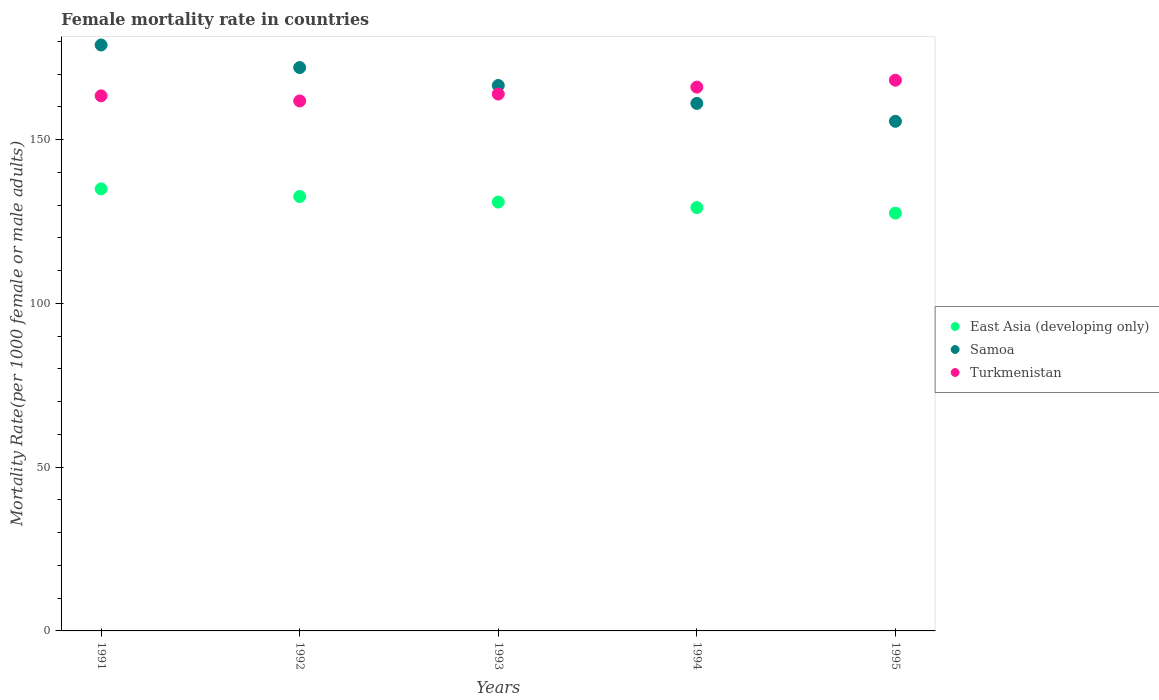How many different coloured dotlines are there?
Keep it short and to the point. 3. What is the female mortality rate in East Asia (developing only) in 1994?
Give a very brief answer. 129.27. Across all years, what is the maximum female mortality rate in Samoa?
Make the answer very short. 178.94. Across all years, what is the minimum female mortality rate in Turkmenistan?
Offer a terse response. 161.84. What is the total female mortality rate in Samoa in the graph?
Give a very brief answer. 834.26. What is the difference between the female mortality rate in Turkmenistan in 1992 and that in 1993?
Give a very brief answer. -2.11. What is the difference between the female mortality rate in Samoa in 1991 and the female mortality rate in East Asia (developing only) in 1992?
Your response must be concise. 46.28. What is the average female mortality rate in Samoa per year?
Your response must be concise. 166.85. In the year 1992, what is the difference between the female mortality rate in Samoa and female mortality rate in Turkmenistan?
Your answer should be compact. 10.2. In how many years, is the female mortality rate in Samoa greater than 40?
Make the answer very short. 5. What is the ratio of the female mortality rate in Samoa in 1992 to that in 1995?
Ensure brevity in your answer.  1.11. Is the difference between the female mortality rate in Samoa in 1992 and 1995 greater than the difference between the female mortality rate in Turkmenistan in 1992 and 1995?
Keep it short and to the point. Yes. What is the difference between the highest and the second highest female mortality rate in Samoa?
Your response must be concise. 6.9. What is the difference between the highest and the lowest female mortality rate in Turkmenistan?
Provide a short and direct response. 6.34. In how many years, is the female mortality rate in East Asia (developing only) greater than the average female mortality rate in East Asia (developing only) taken over all years?
Your response must be concise. 2. Is the sum of the female mortality rate in Turkmenistan in 1993 and 1995 greater than the maximum female mortality rate in East Asia (developing only) across all years?
Provide a succinct answer. Yes. How many dotlines are there?
Keep it short and to the point. 3. What is the difference between two consecutive major ticks on the Y-axis?
Your answer should be very brief. 50. Where does the legend appear in the graph?
Offer a terse response. Center right. How many legend labels are there?
Make the answer very short. 3. How are the legend labels stacked?
Ensure brevity in your answer.  Vertical. What is the title of the graph?
Ensure brevity in your answer.  Female mortality rate in countries. Does "Grenada" appear as one of the legend labels in the graph?
Your answer should be very brief. No. What is the label or title of the X-axis?
Offer a terse response. Years. What is the label or title of the Y-axis?
Keep it short and to the point. Mortality Rate(per 1000 female or male adults). What is the Mortality Rate(per 1000 female or male adults) of East Asia (developing only) in 1991?
Your answer should be very brief. 134.99. What is the Mortality Rate(per 1000 female or male adults) of Samoa in 1991?
Provide a succinct answer. 178.94. What is the Mortality Rate(per 1000 female or male adults) in Turkmenistan in 1991?
Your answer should be very brief. 163.41. What is the Mortality Rate(per 1000 female or male adults) of East Asia (developing only) in 1992?
Give a very brief answer. 132.66. What is the Mortality Rate(per 1000 female or male adults) in Samoa in 1992?
Offer a terse response. 172.04. What is the Mortality Rate(per 1000 female or male adults) in Turkmenistan in 1992?
Offer a terse response. 161.84. What is the Mortality Rate(per 1000 female or male adults) in East Asia (developing only) in 1993?
Your response must be concise. 130.96. What is the Mortality Rate(per 1000 female or male adults) in Samoa in 1993?
Your answer should be compact. 166.57. What is the Mortality Rate(per 1000 female or male adults) in Turkmenistan in 1993?
Your response must be concise. 163.95. What is the Mortality Rate(per 1000 female or male adults) in East Asia (developing only) in 1994?
Your answer should be very brief. 129.27. What is the Mortality Rate(per 1000 female or male adults) in Samoa in 1994?
Give a very brief answer. 161.1. What is the Mortality Rate(per 1000 female or male adults) in Turkmenistan in 1994?
Ensure brevity in your answer.  166.06. What is the Mortality Rate(per 1000 female or male adults) of East Asia (developing only) in 1995?
Your response must be concise. 127.59. What is the Mortality Rate(per 1000 female or male adults) of Samoa in 1995?
Ensure brevity in your answer.  155.63. What is the Mortality Rate(per 1000 female or male adults) in Turkmenistan in 1995?
Give a very brief answer. 168.18. Across all years, what is the maximum Mortality Rate(per 1000 female or male adults) of East Asia (developing only)?
Your answer should be very brief. 134.99. Across all years, what is the maximum Mortality Rate(per 1000 female or male adults) in Samoa?
Give a very brief answer. 178.94. Across all years, what is the maximum Mortality Rate(per 1000 female or male adults) of Turkmenistan?
Offer a very short reply. 168.18. Across all years, what is the minimum Mortality Rate(per 1000 female or male adults) of East Asia (developing only)?
Your answer should be very brief. 127.59. Across all years, what is the minimum Mortality Rate(per 1000 female or male adults) in Samoa?
Provide a short and direct response. 155.63. Across all years, what is the minimum Mortality Rate(per 1000 female or male adults) in Turkmenistan?
Your response must be concise. 161.84. What is the total Mortality Rate(per 1000 female or male adults) in East Asia (developing only) in the graph?
Offer a very short reply. 655.48. What is the total Mortality Rate(per 1000 female or male adults) of Samoa in the graph?
Provide a short and direct response. 834.26. What is the total Mortality Rate(per 1000 female or male adults) in Turkmenistan in the graph?
Offer a very short reply. 823.43. What is the difference between the Mortality Rate(per 1000 female or male adults) of East Asia (developing only) in 1991 and that in 1992?
Give a very brief answer. 2.33. What is the difference between the Mortality Rate(per 1000 female or male adults) of Samoa in 1991 and that in 1992?
Your response must be concise. 6.9. What is the difference between the Mortality Rate(per 1000 female or male adults) in Turkmenistan in 1991 and that in 1992?
Provide a short and direct response. 1.57. What is the difference between the Mortality Rate(per 1000 female or male adults) in East Asia (developing only) in 1991 and that in 1993?
Your response must be concise. 4.03. What is the difference between the Mortality Rate(per 1000 female or male adults) in Samoa in 1991 and that in 1993?
Give a very brief answer. 12.37. What is the difference between the Mortality Rate(per 1000 female or male adults) in Turkmenistan in 1991 and that in 1993?
Offer a terse response. -0.54. What is the difference between the Mortality Rate(per 1000 female or male adults) of East Asia (developing only) in 1991 and that in 1994?
Your response must be concise. 5.72. What is the difference between the Mortality Rate(per 1000 female or male adults) in Samoa in 1991 and that in 1994?
Keep it short and to the point. 17.84. What is the difference between the Mortality Rate(per 1000 female or male adults) of Turkmenistan in 1991 and that in 1994?
Make the answer very short. -2.65. What is the difference between the Mortality Rate(per 1000 female or male adults) in East Asia (developing only) in 1991 and that in 1995?
Offer a terse response. 7.4. What is the difference between the Mortality Rate(per 1000 female or male adults) in Samoa in 1991 and that in 1995?
Ensure brevity in your answer.  23.31. What is the difference between the Mortality Rate(per 1000 female or male adults) in Turkmenistan in 1991 and that in 1995?
Your response must be concise. -4.77. What is the difference between the Mortality Rate(per 1000 female or male adults) in East Asia (developing only) in 1992 and that in 1993?
Keep it short and to the point. 1.7. What is the difference between the Mortality Rate(per 1000 female or male adults) of Samoa in 1992 and that in 1993?
Offer a terse response. 5.47. What is the difference between the Mortality Rate(per 1000 female or male adults) in Turkmenistan in 1992 and that in 1993?
Your answer should be very brief. -2.11. What is the difference between the Mortality Rate(per 1000 female or male adults) in East Asia (developing only) in 1992 and that in 1994?
Offer a terse response. 3.39. What is the difference between the Mortality Rate(per 1000 female or male adults) in Samoa in 1992 and that in 1994?
Give a very brief answer. 10.94. What is the difference between the Mortality Rate(per 1000 female or male adults) of Turkmenistan in 1992 and that in 1994?
Ensure brevity in your answer.  -4.23. What is the difference between the Mortality Rate(per 1000 female or male adults) in East Asia (developing only) in 1992 and that in 1995?
Your answer should be compact. 5.07. What is the difference between the Mortality Rate(per 1000 female or male adults) in Samoa in 1992 and that in 1995?
Provide a succinct answer. 16.41. What is the difference between the Mortality Rate(per 1000 female or male adults) of Turkmenistan in 1992 and that in 1995?
Your response must be concise. -6.34. What is the difference between the Mortality Rate(per 1000 female or male adults) in East Asia (developing only) in 1993 and that in 1994?
Your answer should be very brief. 1.69. What is the difference between the Mortality Rate(per 1000 female or male adults) of Samoa in 1993 and that in 1994?
Make the answer very short. 5.47. What is the difference between the Mortality Rate(per 1000 female or male adults) in Turkmenistan in 1993 and that in 1994?
Provide a short and direct response. -2.11. What is the difference between the Mortality Rate(per 1000 female or male adults) in East Asia (developing only) in 1993 and that in 1995?
Your answer should be very brief. 3.37. What is the difference between the Mortality Rate(per 1000 female or male adults) of Samoa in 1993 and that in 1995?
Offer a very short reply. 10.94. What is the difference between the Mortality Rate(per 1000 female or male adults) of Turkmenistan in 1993 and that in 1995?
Keep it short and to the point. -4.23. What is the difference between the Mortality Rate(per 1000 female or male adults) of East Asia (developing only) in 1994 and that in 1995?
Make the answer very short. 1.68. What is the difference between the Mortality Rate(per 1000 female or male adults) in Samoa in 1994 and that in 1995?
Offer a very short reply. 5.47. What is the difference between the Mortality Rate(per 1000 female or male adults) in Turkmenistan in 1994 and that in 1995?
Your answer should be compact. -2.11. What is the difference between the Mortality Rate(per 1000 female or male adults) in East Asia (developing only) in 1991 and the Mortality Rate(per 1000 female or male adults) in Samoa in 1992?
Make the answer very short. -37.04. What is the difference between the Mortality Rate(per 1000 female or male adults) of East Asia (developing only) in 1991 and the Mortality Rate(per 1000 female or male adults) of Turkmenistan in 1992?
Your response must be concise. -26.84. What is the difference between the Mortality Rate(per 1000 female or male adults) in Samoa in 1991 and the Mortality Rate(per 1000 female or male adults) in Turkmenistan in 1992?
Your response must be concise. 17.1. What is the difference between the Mortality Rate(per 1000 female or male adults) in East Asia (developing only) in 1991 and the Mortality Rate(per 1000 female or male adults) in Samoa in 1993?
Your answer should be very brief. -31.57. What is the difference between the Mortality Rate(per 1000 female or male adults) in East Asia (developing only) in 1991 and the Mortality Rate(per 1000 female or male adults) in Turkmenistan in 1993?
Keep it short and to the point. -28.96. What is the difference between the Mortality Rate(per 1000 female or male adults) of Samoa in 1991 and the Mortality Rate(per 1000 female or male adults) of Turkmenistan in 1993?
Offer a very short reply. 14.99. What is the difference between the Mortality Rate(per 1000 female or male adults) of East Asia (developing only) in 1991 and the Mortality Rate(per 1000 female or male adults) of Samoa in 1994?
Provide a succinct answer. -26.1. What is the difference between the Mortality Rate(per 1000 female or male adults) of East Asia (developing only) in 1991 and the Mortality Rate(per 1000 female or male adults) of Turkmenistan in 1994?
Offer a terse response. -31.07. What is the difference between the Mortality Rate(per 1000 female or male adults) of Samoa in 1991 and the Mortality Rate(per 1000 female or male adults) of Turkmenistan in 1994?
Provide a short and direct response. 12.87. What is the difference between the Mortality Rate(per 1000 female or male adults) of East Asia (developing only) in 1991 and the Mortality Rate(per 1000 female or male adults) of Samoa in 1995?
Provide a succinct answer. -20.63. What is the difference between the Mortality Rate(per 1000 female or male adults) of East Asia (developing only) in 1991 and the Mortality Rate(per 1000 female or male adults) of Turkmenistan in 1995?
Offer a very short reply. -33.18. What is the difference between the Mortality Rate(per 1000 female or male adults) of Samoa in 1991 and the Mortality Rate(per 1000 female or male adults) of Turkmenistan in 1995?
Keep it short and to the point. 10.76. What is the difference between the Mortality Rate(per 1000 female or male adults) in East Asia (developing only) in 1992 and the Mortality Rate(per 1000 female or male adults) in Samoa in 1993?
Make the answer very short. -33.91. What is the difference between the Mortality Rate(per 1000 female or male adults) of East Asia (developing only) in 1992 and the Mortality Rate(per 1000 female or male adults) of Turkmenistan in 1993?
Your answer should be compact. -31.29. What is the difference between the Mortality Rate(per 1000 female or male adults) in Samoa in 1992 and the Mortality Rate(per 1000 female or male adults) in Turkmenistan in 1993?
Provide a short and direct response. 8.09. What is the difference between the Mortality Rate(per 1000 female or male adults) in East Asia (developing only) in 1992 and the Mortality Rate(per 1000 female or male adults) in Samoa in 1994?
Ensure brevity in your answer.  -28.44. What is the difference between the Mortality Rate(per 1000 female or male adults) in East Asia (developing only) in 1992 and the Mortality Rate(per 1000 female or male adults) in Turkmenistan in 1994?
Give a very brief answer. -33.4. What is the difference between the Mortality Rate(per 1000 female or male adults) of Samoa in 1992 and the Mortality Rate(per 1000 female or male adults) of Turkmenistan in 1994?
Ensure brevity in your answer.  5.97. What is the difference between the Mortality Rate(per 1000 female or male adults) of East Asia (developing only) in 1992 and the Mortality Rate(per 1000 female or male adults) of Samoa in 1995?
Keep it short and to the point. -22.97. What is the difference between the Mortality Rate(per 1000 female or male adults) of East Asia (developing only) in 1992 and the Mortality Rate(per 1000 female or male adults) of Turkmenistan in 1995?
Your response must be concise. -35.52. What is the difference between the Mortality Rate(per 1000 female or male adults) in Samoa in 1992 and the Mortality Rate(per 1000 female or male adults) in Turkmenistan in 1995?
Offer a terse response. 3.86. What is the difference between the Mortality Rate(per 1000 female or male adults) in East Asia (developing only) in 1993 and the Mortality Rate(per 1000 female or male adults) in Samoa in 1994?
Give a very brief answer. -30.13. What is the difference between the Mortality Rate(per 1000 female or male adults) of East Asia (developing only) in 1993 and the Mortality Rate(per 1000 female or male adults) of Turkmenistan in 1994?
Keep it short and to the point. -35.1. What is the difference between the Mortality Rate(per 1000 female or male adults) of Samoa in 1993 and the Mortality Rate(per 1000 female or male adults) of Turkmenistan in 1994?
Provide a succinct answer. 0.51. What is the difference between the Mortality Rate(per 1000 female or male adults) of East Asia (developing only) in 1993 and the Mortality Rate(per 1000 female or male adults) of Samoa in 1995?
Offer a terse response. -24.66. What is the difference between the Mortality Rate(per 1000 female or male adults) of East Asia (developing only) in 1993 and the Mortality Rate(per 1000 female or male adults) of Turkmenistan in 1995?
Provide a succinct answer. -37.21. What is the difference between the Mortality Rate(per 1000 female or male adults) of Samoa in 1993 and the Mortality Rate(per 1000 female or male adults) of Turkmenistan in 1995?
Your response must be concise. -1.61. What is the difference between the Mortality Rate(per 1000 female or male adults) in East Asia (developing only) in 1994 and the Mortality Rate(per 1000 female or male adults) in Samoa in 1995?
Make the answer very short. -26.35. What is the difference between the Mortality Rate(per 1000 female or male adults) of East Asia (developing only) in 1994 and the Mortality Rate(per 1000 female or male adults) of Turkmenistan in 1995?
Provide a succinct answer. -38.9. What is the difference between the Mortality Rate(per 1000 female or male adults) of Samoa in 1994 and the Mortality Rate(per 1000 female or male adults) of Turkmenistan in 1995?
Your answer should be very brief. -7.08. What is the average Mortality Rate(per 1000 female or male adults) of East Asia (developing only) per year?
Your response must be concise. 131.1. What is the average Mortality Rate(per 1000 female or male adults) in Samoa per year?
Ensure brevity in your answer.  166.85. What is the average Mortality Rate(per 1000 female or male adults) of Turkmenistan per year?
Your response must be concise. 164.69. In the year 1991, what is the difference between the Mortality Rate(per 1000 female or male adults) of East Asia (developing only) and Mortality Rate(per 1000 female or male adults) of Samoa?
Keep it short and to the point. -43.94. In the year 1991, what is the difference between the Mortality Rate(per 1000 female or male adults) in East Asia (developing only) and Mortality Rate(per 1000 female or male adults) in Turkmenistan?
Your response must be concise. -28.41. In the year 1991, what is the difference between the Mortality Rate(per 1000 female or male adults) in Samoa and Mortality Rate(per 1000 female or male adults) in Turkmenistan?
Provide a short and direct response. 15.53. In the year 1992, what is the difference between the Mortality Rate(per 1000 female or male adults) in East Asia (developing only) and Mortality Rate(per 1000 female or male adults) in Samoa?
Provide a succinct answer. -39.38. In the year 1992, what is the difference between the Mortality Rate(per 1000 female or male adults) of East Asia (developing only) and Mortality Rate(per 1000 female or male adults) of Turkmenistan?
Your response must be concise. -29.18. In the year 1992, what is the difference between the Mortality Rate(per 1000 female or male adults) of Samoa and Mortality Rate(per 1000 female or male adults) of Turkmenistan?
Your answer should be very brief. 10.2. In the year 1993, what is the difference between the Mortality Rate(per 1000 female or male adults) in East Asia (developing only) and Mortality Rate(per 1000 female or male adults) in Samoa?
Offer a very short reply. -35.6. In the year 1993, what is the difference between the Mortality Rate(per 1000 female or male adults) in East Asia (developing only) and Mortality Rate(per 1000 female or male adults) in Turkmenistan?
Your answer should be compact. -32.99. In the year 1993, what is the difference between the Mortality Rate(per 1000 female or male adults) in Samoa and Mortality Rate(per 1000 female or male adults) in Turkmenistan?
Provide a short and direct response. 2.62. In the year 1994, what is the difference between the Mortality Rate(per 1000 female or male adults) in East Asia (developing only) and Mortality Rate(per 1000 female or male adults) in Samoa?
Offer a terse response. -31.83. In the year 1994, what is the difference between the Mortality Rate(per 1000 female or male adults) of East Asia (developing only) and Mortality Rate(per 1000 female or male adults) of Turkmenistan?
Offer a terse response. -36.79. In the year 1994, what is the difference between the Mortality Rate(per 1000 female or male adults) in Samoa and Mortality Rate(per 1000 female or male adults) in Turkmenistan?
Keep it short and to the point. -4.97. In the year 1995, what is the difference between the Mortality Rate(per 1000 female or male adults) in East Asia (developing only) and Mortality Rate(per 1000 female or male adults) in Samoa?
Provide a short and direct response. -28.03. In the year 1995, what is the difference between the Mortality Rate(per 1000 female or male adults) of East Asia (developing only) and Mortality Rate(per 1000 female or male adults) of Turkmenistan?
Ensure brevity in your answer.  -40.58. In the year 1995, what is the difference between the Mortality Rate(per 1000 female or male adults) in Samoa and Mortality Rate(per 1000 female or male adults) in Turkmenistan?
Make the answer very short. -12.55. What is the ratio of the Mortality Rate(per 1000 female or male adults) of East Asia (developing only) in 1991 to that in 1992?
Your response must be concise. 1.02. What is the ratio of the Mortality Rate(per 1000 female or male adults) of Samoa in 1991 to that in 1992?
Make the answer very short. 1.04. What is the ratio of the Mortality Rate(per 1000 female or male adults) in Turkmenistan in 1991 to that in 1992?
Offer a terse response. 1.01. What is the ratio of the Mortality Rate(per 1000 female or male adults) of East Asia (developing only) in 1991 to that in 1993?
Provide a succinct answer. 1.03. What is the ratio of the Mortality Rate(per 1000 female or male adults) of Samoa in 1991 to that in 1993?
Offer a terse response. 1.07. What is the ratio of the Mortality Rate(per 1000 female or male adults) of East Asia (developing only) in 1991 to that in 1994?
Provide a succinct answer. 1.04. What is the ratio of the Mortality Rate(per 1000 female or male adults) of Samoa in 1991 to that in 1994?
Make the answer very short. 1.11. What is the ratio of the Mortality Rate(per 1000 female or male adults) of East Asia (developing only) in 1991 to that in 1995?
Keep it short and to the point. 1.06. What is the ratio of the Mortality Rate(per 1000 female or male adults) of Samoa in 1991 to that in 1995?
Provide a short and direct response. 1.15. What is the ratio of the Mortality Rate(per 1000 female or male adults) in Turkmenistan in 1991 to that in 1995?
Provide a short and direct response. 0.97. What is the ratio of the Mortality Rate(per 1000 female or male adults) of East Asia (developing only) in 1992 to that in 1993?
Offer a terse response. 1.01. What is the ratio of the Mortality Rate(per 1000 female or male adults) of Samoa in 1992 to that in 1993?
Offer a very short reply. 1.03. What is the ratio of the Mortality Rate(per 1000 female or male adults) in Turkmenistan in 1992 to that in 1993?
Provide a succinct answer. 0.99. What is the ratio of the Mortality Rate(per 1000 female or male adults) of East Asia (developing only) in 1992 to that in 1994?
Provide a short and direct response. 1.03. What is the ratio of the Mortality Rate(per 1000 female or male adults) of Samoa in 1992 to that in 1994?
Give a very brief answer. 1.07. What is the ratio of the Mortality Rate(per 1000 female or male adults) of Turkmenistan in 1992 to that in 1994?
Offer a terse response. 0.97. What is the ratio of the Mortality Rate(per 1000 female or male adults) in East Asia (developing only) in 1992 to that in 1995?
Offer a terse response. 1.04. What is the ratio of the Mortality Rate(per 1000 female or male adults) of Samoa in 1992 to that in 1995?
Keep it short and to the point. 1.11. What is the ratio of the Mortality Rate(per 1000 female or male adults) of Turkmenistan in 1992 to that in 1995?
Give a very brief answer. 0.96. What is the ratio of the Mortality Rate(per 1000 female or male adults) in East Asia (developing only) in 1993 to that in 1994?
Your answer should be compact. 1.01. What is the ratio of the Mortality Rate(per 1000 female or male adults) in Samoa in 1993 to that in 1994?
Give a very brief answer. 1.03. What is the ratio of the Mortality Rate(per 1000 female or male adults) of Turkmenistan in 1993 to that in 1994?
Your answer should be very brief. 0.99. What is the ratio of the Mortality Rate(per 1000 female or male adults) in East Asia (developing only) in 1993 to that in 1995?
Keep it short and to the point. 1.03. What is the ratio of the Mortality Rate(per 1000 female or male adults) in Samoa in 1993 to that in 1995?
Make the answer very short. 1.07. What is the ratio of the Mortality Rate(per 1000 female or male adults) of Turkmenistan in 1993 to that in 1995?
Offer a terse response. 0.97. What is the ratio of the Mortality Rate(per 1000 female or male adults) of East Asia (developing only) in 1994 to that in 1995?
Provide a short and direct response. 1.01. What is the ratio of the Mortality Rate(per 1000 female or male adults) of Samoa in 1994 to that in 1995?
Your answer should be compact. 1.04. What is the ratio of the Mortality Rate(per 1000 female or male adults) in Turkmenistan in 1994 to that in 1995?
Give a very brief answer. 0.99. What is the difference between the highest and the second highest Mortality Rate(per 1000 female or male adults) in East Asia (developing only)?
Your response must be concise. 2.33. What is the difference between the highest and the second highest Mortality Rate(per 1000 female or male adults) of Samoa?
Give a very brief answer. 6.9. What is the difference between the highest and the second highest Mortality Rate(per 1000 female or male adults) in Turkmenistan?
Offer a terse response. 2.11. What is the difference between the highest and the lowest Mortality Rate(per 1000 female or male adults) in East Asia (developing only)?
Provide a succinct answer. 7.4. What is the difference between the highest and the lowest Mortality Rate(per 1000 female or male adults) in Samoa?
Provide a short and direct response. 23.31. What is the difference between the highest and the lowest Mortality Rate(per 1000 female or male adults) in Turkmenistan?
Provide a short and direct response. 6.34. 